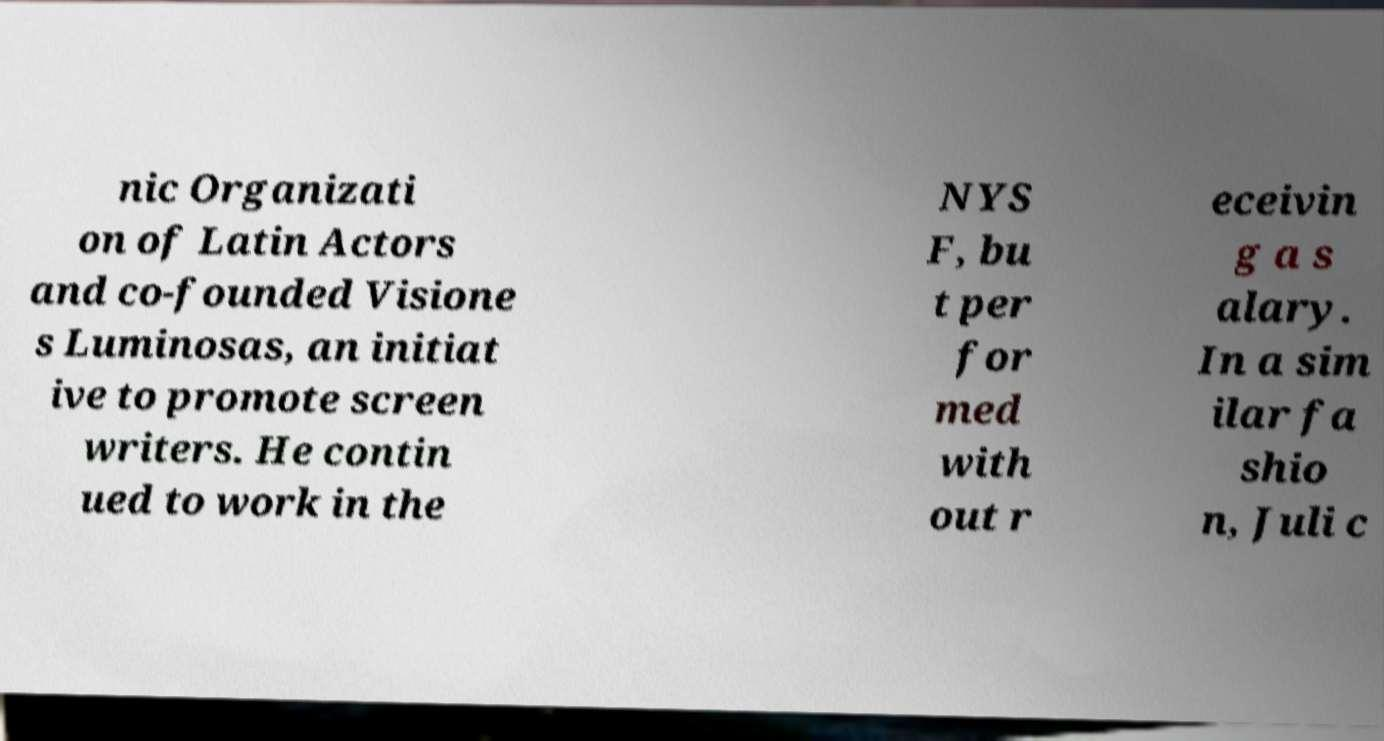What messages or text are displayed in this image? I need them in a readable, typed format. nic Organizati on of Latin Actors and co-founded Visione s Luminosas, an initiat ive to promote screen writers. He contin ued to work in the NYS F, bu t per for med with out r eceivin g a s alary. In a sim ilar fa shio n, Juli c 